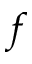Convert formula to latex. <formula><loc_0><loc_0><loc_500><loc_500>f</formula> 